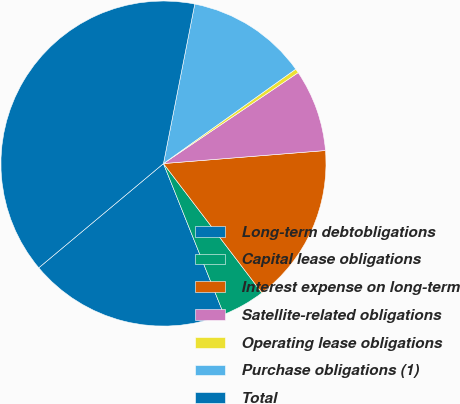Convert chart to OTSL. <chart><loc_0><loc_0><loc_500><loc_500><pie_chart><fcel>Long-term debtobligations<fcel>Capital lease obligations<fcel>Interest expense on long-term<fcel>Satellite-related obligations<fcel>Operating lease obligations<fcel>Purchase obligations (1)<fcel>Total<nl><fcel>19.98%<fcel>4.3%<fcel>15.92%<fcel>8.17%<fcel>0.42%<fcel>12.05%<fcel>39.17%<nl></chart> 